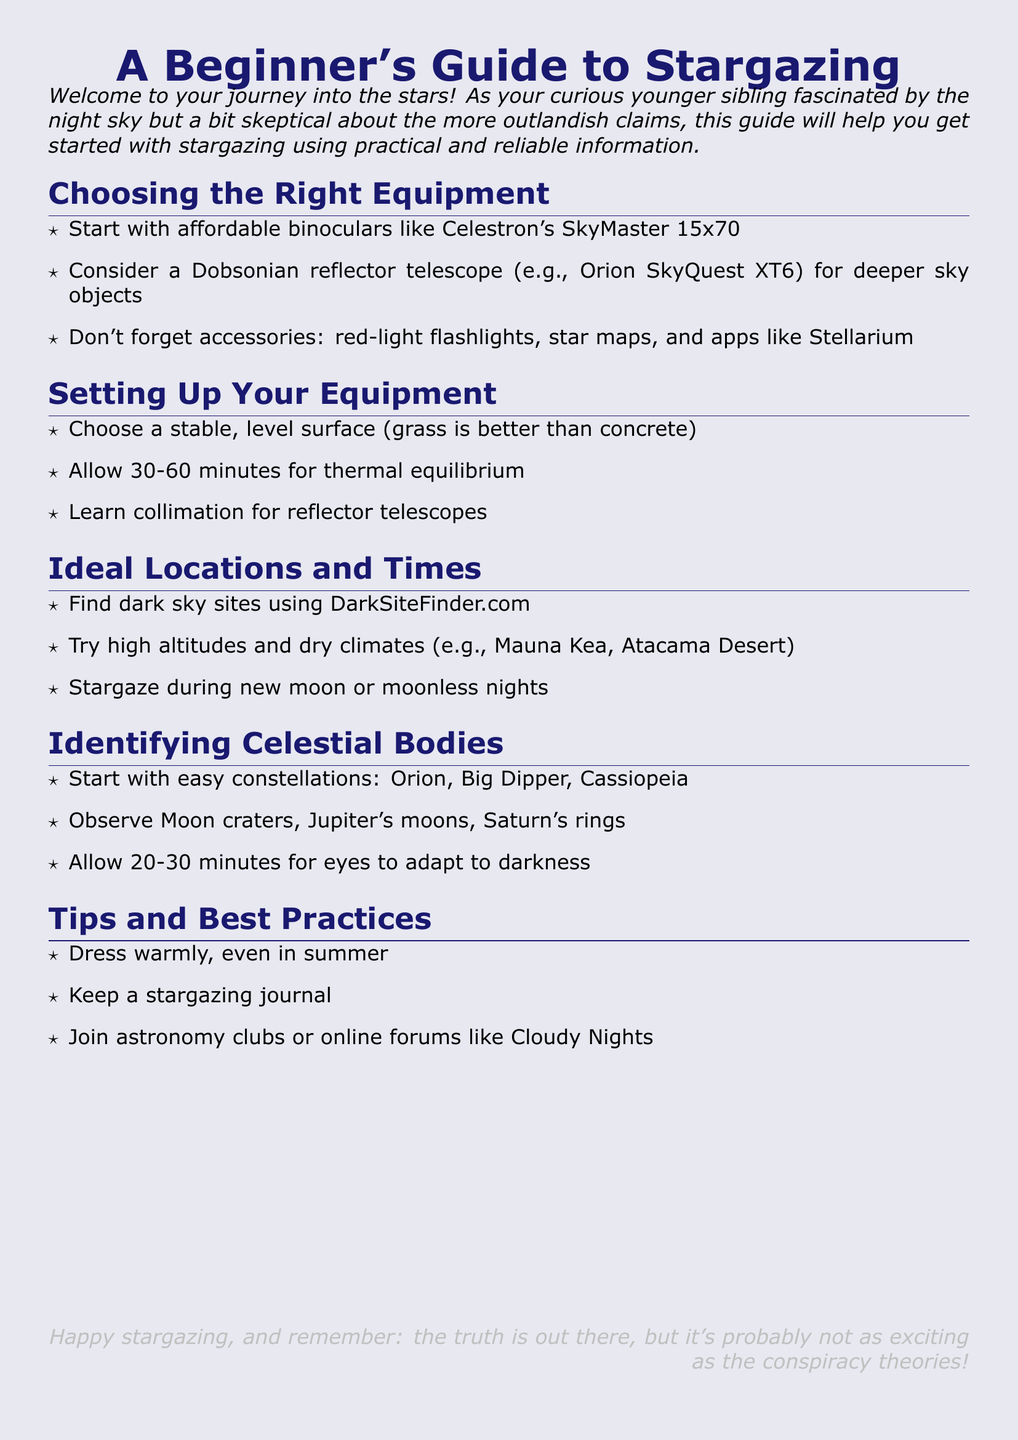What is recommended for beginners to start stargazing? The document suggests starting with affordable binoculars like Celestron's SkyMaster 15x70.
Answer: Celestron's SkyMaster 15x70 How much time should you allow for thermal equilibrium? The document states to allow 30-60 minutes for thermal equilibrium when setting up your equipment.
Answer: 30-60 minutes Which dark sky site finder is mentioned? The document specifies using DarkSiteFinder.com to find dark sky sites.
Answer: DarkSiteFinder.com What are two ideal conditions for stargazing mentioned? The document advises stargazing during new moon or moonless nights in high altitudes and dry climates.
Answer: New moon or moonless nights What should you do to adapt your eyes to darkness? The document recommends allowing 20-30 minutes for your eyes to adapt to darkness.
Answer: 20-30 minutes What should you keep while stargazing? The document suggests keeping a stargazing journal as a best practice.
Answer: Stargazing journal Which constellations are suggested for beginners to start with? The document lists Orion, Big Dipper, and Cassiopeia as easy constellations to start with.
Answer: Orion, Big Dipper, Cassiopeia What type of telescope is recommended for deeper sky objects? The document recommends a Dobsonian reflector telescope, for example, Orion SkyQuest XT6.
Answer: Dobsonian reflector telescope What is suggested to help you find other enthusiasts? The document advises joining astronomy clubs or online forums like Cloudy Nights.
Answer: Astronomy clubs or Cloudy Nights 